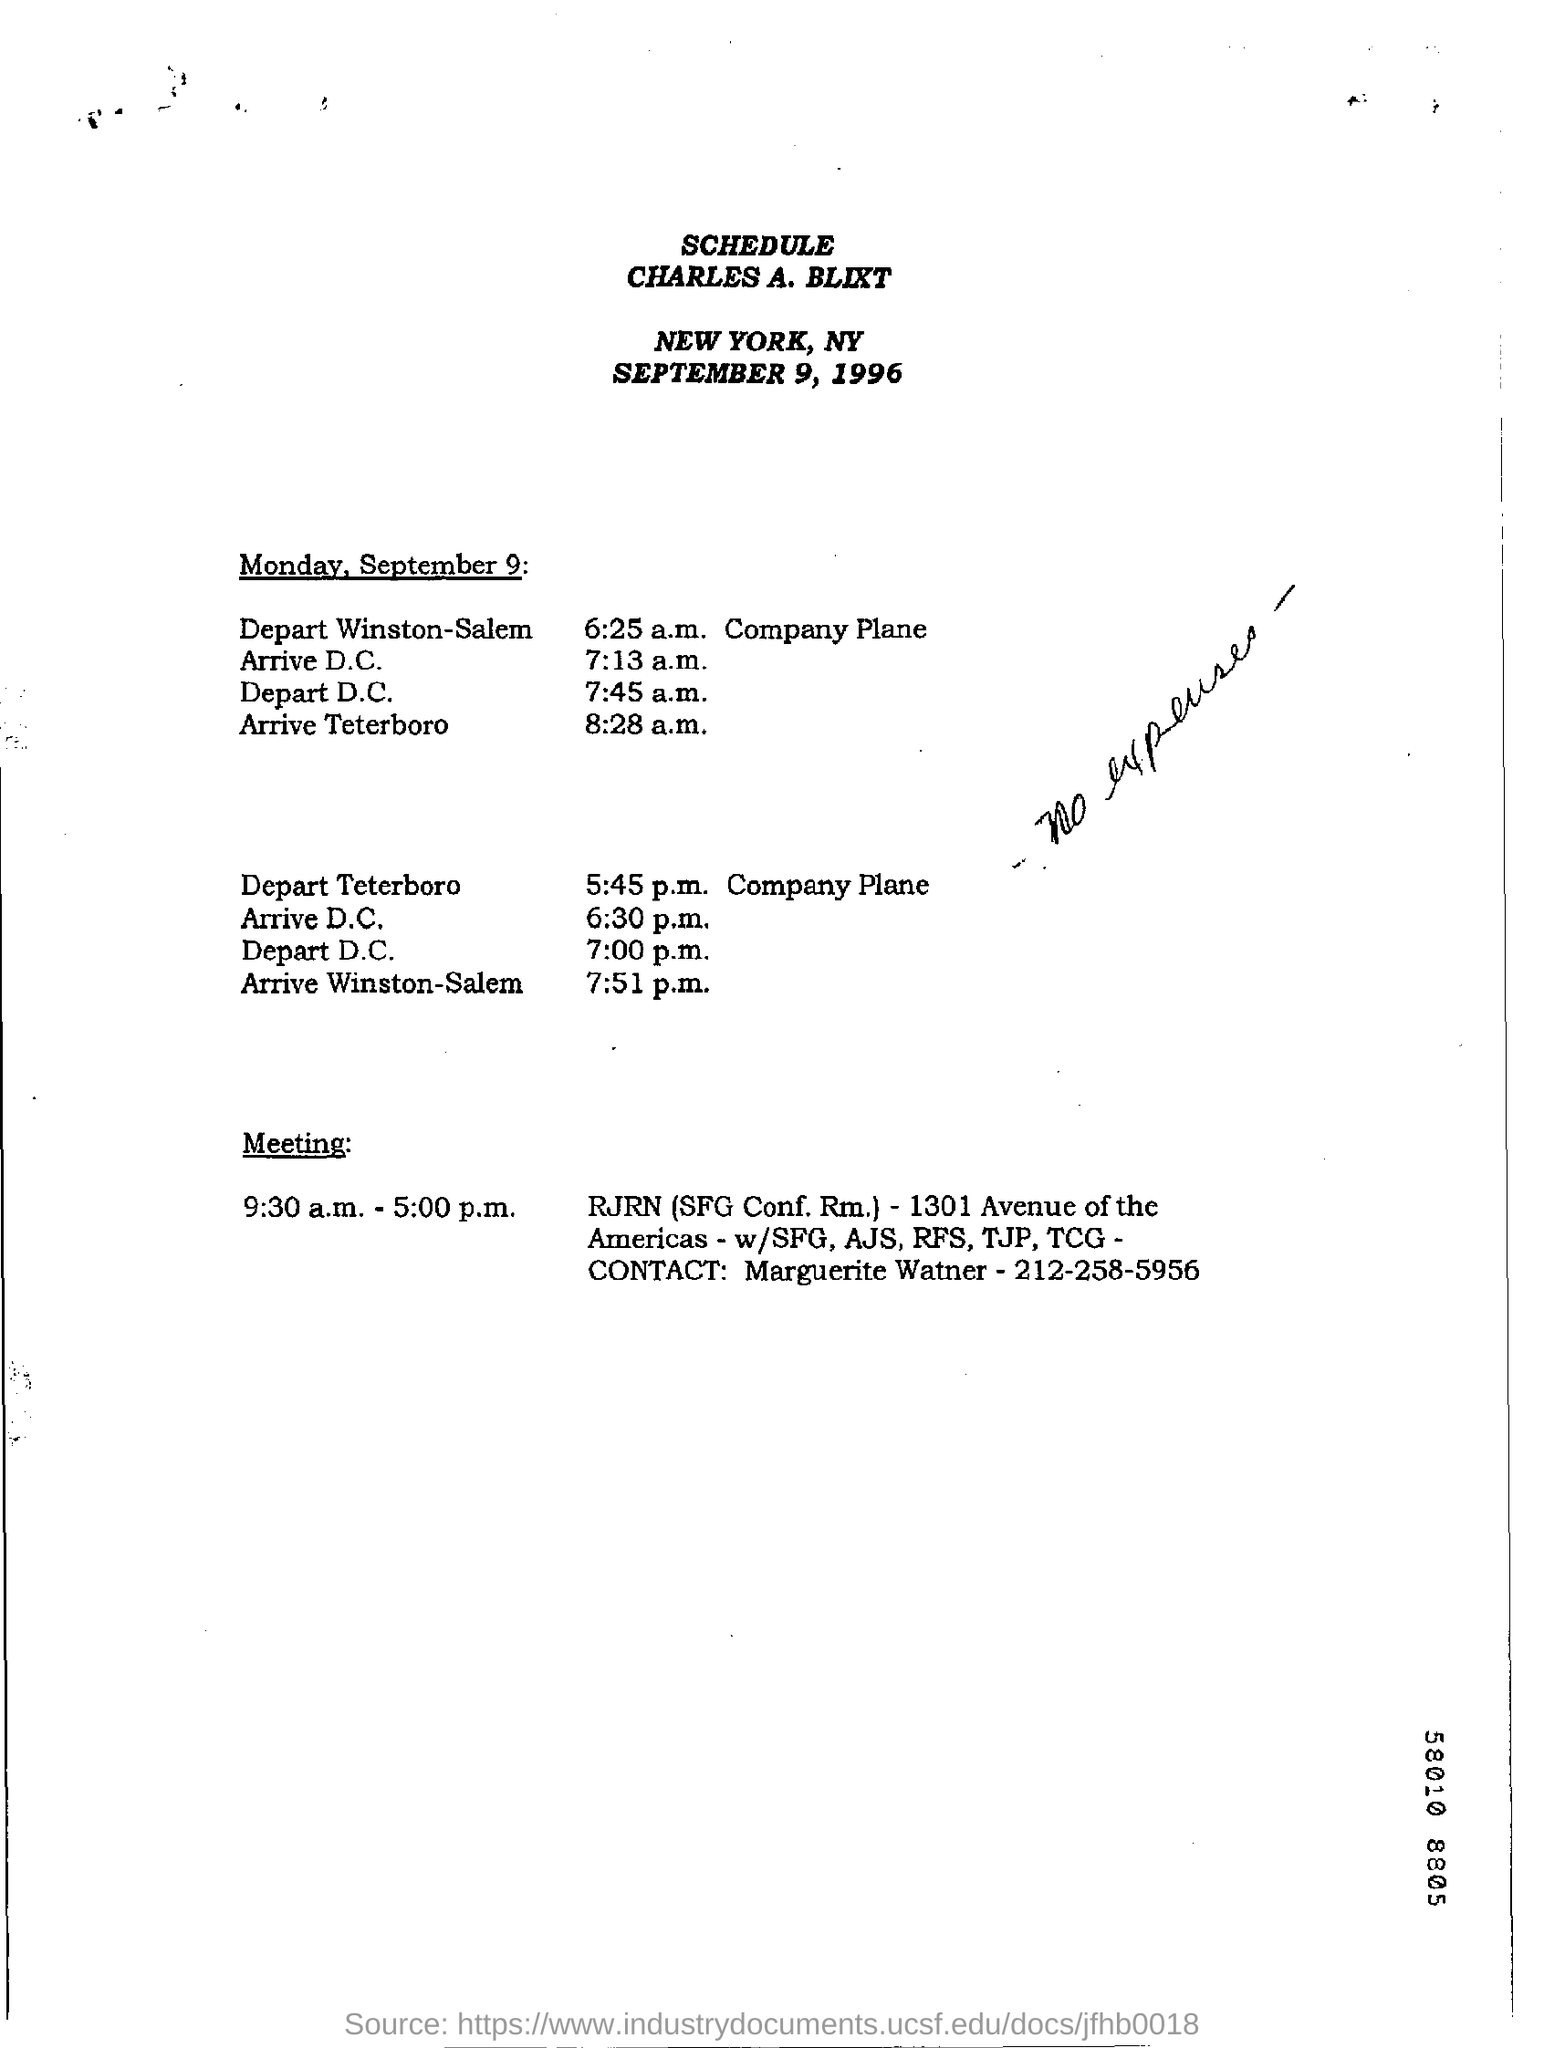What is Marguerite Watner's contact number?
Provide a short and direct response. 212-258-5956. What is handwritten on the document?
Make the answer very short. No expenses. Whose name appears on top of the schedule?
Your response must be concise. CHARLES A. BLIXT. When is the schedule dated?
Your answer should be compact. SEPTEMBER 9, 1996. 